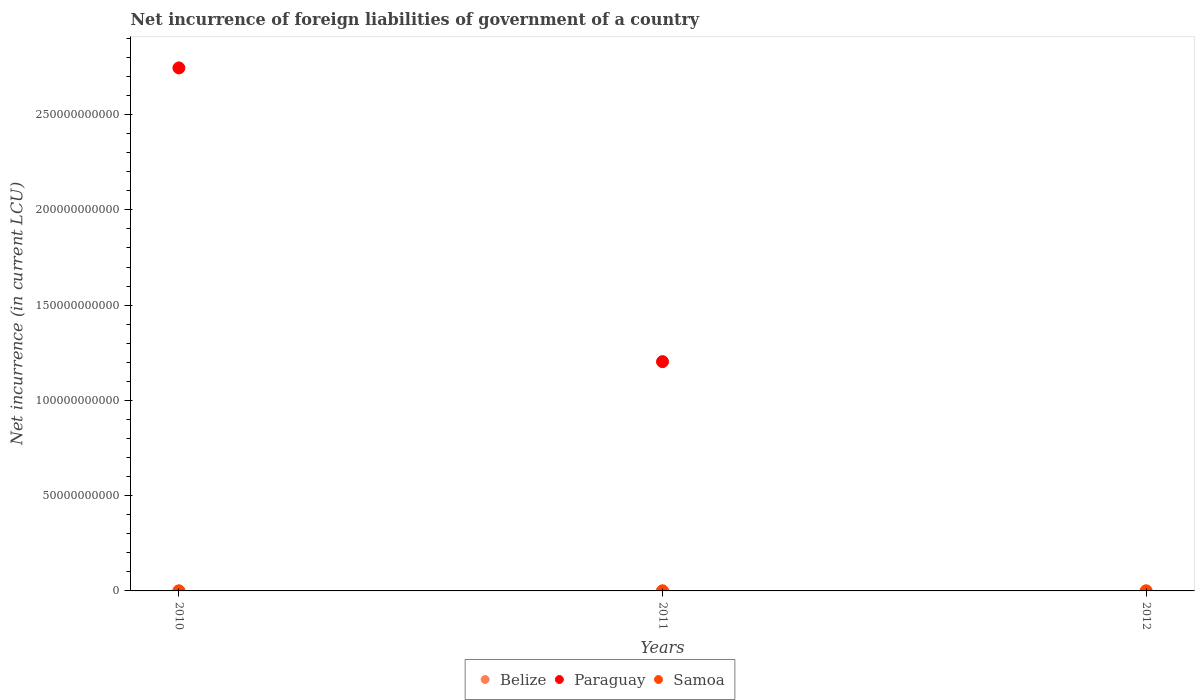How many different coloured dotlines are there?
Offer a very short reply. 3. Is the number of dotlines equal to the number of legend labels?
Provide a short and direct response. No. What is the net incurrence of foreign liabilities in Belize in 2011?
Make the answer very short. 2.52e+07. Across all years, what is the maximum net incurrence of foreign liabilities in Paraguay?
Make the answer very short. 2.74e+11. Across all years, what is the minimum net incurrence of foreign liabilities in Samoa?
Give a very brief answer. 9.67e+04. What is the total net incurrence of foreign liabilities in Paraguay in the graph?
Provide a succinct answer. 3.95e+11. What is the difference between the net incurrence of foreign liabilities in Samoa in 2010 and that in 2011?
Make the answer very short. 4.58e+04. What is the difference between the net incurrence of foreign liabilities in Paraguay in 2011 and the net incurrence of foreign liabilities in Samoa in 2010?
Provide a succinct answer. 1.20e+11. What is the average net incurrence of foreign liabilities in Samoa per year?
Provide a short and direct response. 1.24e+05. In the year 2011, what is the difference between the net incurrence of foreign liabilities in Paraguay and net incurrence of foreign liabilities in Belize?
Your response must be concise. 1.20e+11. What is the ratio of the net incurrence of foreign liabilities in Samoa in 2011 to that in 2012?
Your response must be concise. 0.72. Is the net incurrence of foreign liabilities in Paraguay in 2010 less than that in 2011?
Your response must be concise. No. What is the difference between the highest and the second highest net incurrence of foreign liabilities in Samoa?
Keep it short and to the point. 8704.94. What is the difference between the highest and the lowest net incurrence of foreign liabilities in Belize?
Provide a short and direct response. 3.86e+07. Is it the case that in every year, the sum of the net incurrence of foreign liabilities in Samoa and net incurrence of foreign liabilities in Belize  is greater than the net incurrence of foreign liabilities in Paraguay?
Your answer should be very brief. No. Does the net incurrence of foreign liabilities in Paraguay monotonically increase over the years?
Your answer should be very brief. No. Is the net incurrence of foreign liabilities in Paraguay strictly greater than the net incurrence of foreign liabilities in Samoa over the years?
Your response must be concise. No. What is the difference between two consecutive major ticks on the Y-axis?
Offer a very short reply. 5.00e+1. Does the graph contain any zero values?
Your answer should be very brief. Yes. Where does the legend appear in the graph?
Offer a terse response. Bottom center. How many legend labels are there?
Give a very brief answer. 3. What is the title of the graph?
Make the answer very short. Net incurrence of foreign liabilities of government of a country. What is the label or title of the X-axis?
Provide a short and direct response. Years. What is the label or title of the Y-axis?
Keep it short and to the point. Net incurrence (in current LCU). What is the Net incurrence (in current LCU) of Belize in 2010?
Offer a terse response. 2.74e+06. What is the Net incurrence (in current LCU) in Paraguay in 2010?
Keep it short and to the point. 2.74e+11. What is the Net incurrence (in current LCU) of Samoa in 2010?
Offer a terse response. 1.43e+05. What is the Net incurrence (in current LCU) of Belize in 2011?
Your answer should be compact. 2.52e+07. What is the Net incurrence (in current LCU) in Paraguay in 2011?
Ensure brevity in your answer.  1.20e+11. What is the Net incurrence (in current LCU) of Samoa in 2011?
Keep it short and to the point. 9.67e+04. What is the Net incurrence (in current LCU) in Belize in 2012?
Your answer should be compact. 4.13e+07. What is the Net incurrence (in current LCU) in Paraguay in 2012?
Offer a very short reply. 0. What is the Net incurrence (in current LCU) of Samoa in 2012?
Ensure brevity in your answer.  1.34e+05. Across all years, what is the maximum Net incurrence (in current LCU) in Belize?
Ensure brevity in your answer.  4.13e+07. Across all years, what is the maximum Net incurrence (in current LCU) in Paraguay?
Your answer should be very brief. 2.74e+11. Across all years, what is the maximum Net incurrence (in current LCU) of Samoa?
Offer a terse response. 1.43e+05. Across all years, what is the minimum Net incurrence (in current LCU) in Belize?
Provide a short and direct response. 2.74e+06. Across all years, what is the minimum Net incurrence (in current LCU) in Samoa?
Your answer should be compact. 9.67e+04. What is the total Net incurrence (in current LCU) of Belize in the graph?
Offer a terse response. 6.93e+07. What is the total Net incurrence (in current LCU) of Paraguay in the graph?
Ensure brevity in your answer.  3.95e+11. What is the total Net incurrence (in current LCU) of Samoa in the graph?
Provide a succinct answer. 3.73e+05. What is the difference between the Net incurrence (in current LCU) of Belize in 2010 and that in 2011?
Offer a terse response. -2.25e+07. What is the difference between the Net incurrence (in current LCU) of Paraguay in 2010 and that in 2011?
Keep it short and to the point. 1.54e+11. What is the difference between the Net incurrence (in current LCU) of Samoa in 2010 and that in 2011?
Offer a very short reply. 4.58e+04. What is the difference between the Net incurrence (in current LCU) in Belize in 2010 and that in 2012?
Offer a terse response. -3.86e+07. What is the difference between the Net incurrence (in current LCU) in Samoa in 2010 and that in 2012?
Give a very brief answer. 8704.94. What is the difference between the Net incurrence (in current LCU) in Belize in 2011 and that in 2012?
Your response must be concise. -1.61e+07. What is the difference between the Net incurrence (in current LCU) of Samoa in 2011 and that in 2012?
Ensure brevity in your answer.  -3.71e+04. What is the difference between the Net incurrence (in current LCU) in Belize in 2010 and the Net incurrence (in current LCU) in Paraguay in 2011?
Provide a succinct answer. -1.20e+11. What is the difference between the Net incurrence (in current LCU) in Belize in 2010 and the Net incurrence (in current LCU) in Samoa in 2011?
Ensure brevity in your answer.  2.64e+06. What is the difference between the Net incurrence (in current LCU) of Paraguay in 2010 and the Net incurrence (in current LCU) of Samoa in 2011?
Give a very brief answer. 2.74e+11. What is the difference between the Net incurrence (in current LCU) in Belize in 2010 and the Net incurrence (in current LCU) in Samoa in 2012?
Your response must be concise. 2.60e+06. What is the difference between the Net incurrence (in current LCU) of Paraguay in 2010 and the Net incurrence (in current LCU) of Samoa in 2012?
Ensure brevity in your answer.  2.74e+11. What is the difference between the Net incurrence (in current LCU) in Belize in 2011 and the Net incurrence (in current LCU) in Samoa in 2012?
Your answer should be very brief. 2.51e+07. What is the difference between the Net incurrence (in current LCU) of Paraguay in 2011 and the Net incurrence (in current LCU) of Samoa in 2012?
Make the answer very short. 1.20e+11. What is the average Net incurrence (in current LCU) of Belize per year?
Provide a succinct answer. 2.31e+07. What is the average Net incurrence (in current LCU) of Paraguay per year?
Ensure brevity in your answer.  1.32e+11. What is the average Net incurrence (in current LCU) of Samoa per year?
Offer a very short reply. 1.24e+05. In the year 2010, what is the difference between the Net incurrence (in current LCU) in Belize and Net incurrence (in current LCU) in Paraguay?
Provide a short and direct response. -2.74e+11. In the year 2010, what is the difference between the Net incurrence (in current LCU) in Belize and Net incurrence (in current LCU) in Samoa?
Your answer should be compact. 2.59e+06. In the year 2010, what is the difference between the Net incurrence (in current LCU) of Paraguay and Net incurrence (in current LCU) of Samoa?
Keep it short and to the point. 2.74e+11. In the year 2011, what is the difference between the Net incurrence (in current LCU) of Belize and Net incurrence (in current LCU) of Paraguay?
Your response must be concise. -1.20e+11. In the year 2011, what is the difference between the Net incurrence (in current LCU) in Belize and Net incurrence (in current LCU) in Samoa?
Your answer should be compact. 2.51e+07. In the year 2011, what is the difference between the Net incurrence (in current LCU) of Paraguay and Net incurrence (in current LCU) of Samoa?
Your answer should be very brief. 1.20e+11. In the year 2012, what is the difference between the Net incurrence (in current LCU) in Belize and Net incurrence (in current LCU) in Samoa?
Offer a terse response. 4.12e+07. What is the ratio of the Net incurrence (in current LCU) in Belize in 2010 to that in 2011?
Provide a succinct answer. 0.11. What is the ratio of the Net incurrence (in current LCU) of Paraguay in 2010 to that in 2011?
Your answer should be compact. 2.28. What is the ratio of the Net incurrence (in current LCU) of Samoa in 2010 to that in 2011?
Offer a terse response. 1.47. What is the ratio of the Net incurrence (in current LCU) in Belize in 2010 to that in 2012?
Your response must be concise. 0.07. What is the ratio of the Net incurrence (in current LCU) in Samoa in 2010 to that in 2012?
Give a very brief answer. 1.07. What is the ratio of the Net incurrence (in current LCU) in Belize in 2011 to that in 2012?
Your answer should be very brief. 0.61. What is the ratio of the Net incurrence (in current LCU) in Samoa in 2011 to that in 2012?
Make the answer very short. 0.72. What is the difference between the highest and the second highest Net incurrence (in current LCU) of Belize?
Your answer should be compact. 1.61e+07. What is the difference between the highest and the second highest Net incurrence (in current LCU) of Samoa?
Your answer should be very brief. 8704.94. What is the difference between the highest and the lowest Net incurrence (in current LCU) in Belize?
Ensure brevity in your answer.  3.86e+07. What is the difference between the highest and the lowest Net incurrence (in current LCU) in Paraguay?
Offer a very short reply. 2.74e+11. What is the difference between the highest and the lowest Net incurrence (in current LCU) of Samoa?
Provide a succinct answer. 4.58e+04. 